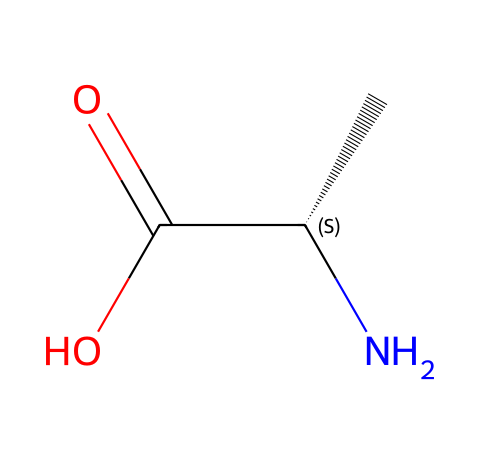What is the molecular formula of this amino acid? The molecular formula can be determined by counting the atoms represented in the SMILES notation. The structure contains 5 carbon atoms, 9 hydrogen atoms, 1 nitrogen atom, and 2 oxygen atoms, leading to the formula C5H9NO2.
Answer: C5H9NO2 How many carbon atoms are present in this structure? By examining the SMILES representation, we can identify each carbon ('C') symbol. The structure has 5 carbon atoms, as indicated by the 'C' notations.
Answer: 5 What type of functional group is present in this amino acid? The chemical has a carboxylic acid functional group, seen from the 'C(=O)O' section, which indicates the presence of a carboxyl (-COOH) group.
Answer: carboxylic acid What is the stereochemistry of the chiral center? The notation 'C@@H' indicates that the molecule contains a chiral carbon atom with a specific stereochemistry. The 'C@@' signifies that this carbon is in the S configuration according to the Cahn-Ingold-Prelog priority rules.
Answer: S Which atom indicates that this compound is an amino acid? The presence of the amino group, which can be recognized as 'N' at the beginning of the SMILES, confirms this compound is an amino acid.
Answer: N What is the role of the nitrogen atom in this molecule? The nitrogen atom in the structure represents the amino group (-NH2), which is essential for classifying the compound as an amino acid, contributing to its properties and reactivity.
Answer: amino group 